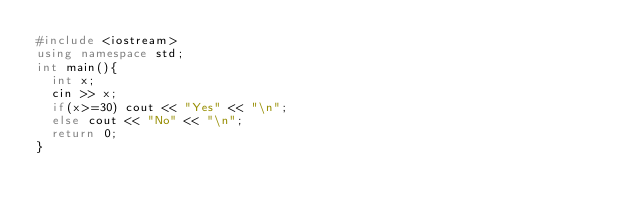<code> <loc_0><loc_0><loc_500><loc_500><_C++_>#include <iostream>
using namespace std;
int main(){
  int x;
  cin >> x;             
  if(x>=30) cout << "Yes" << "\n";    
  else cout << "No" << "\n";
  return 0;
}</code> 